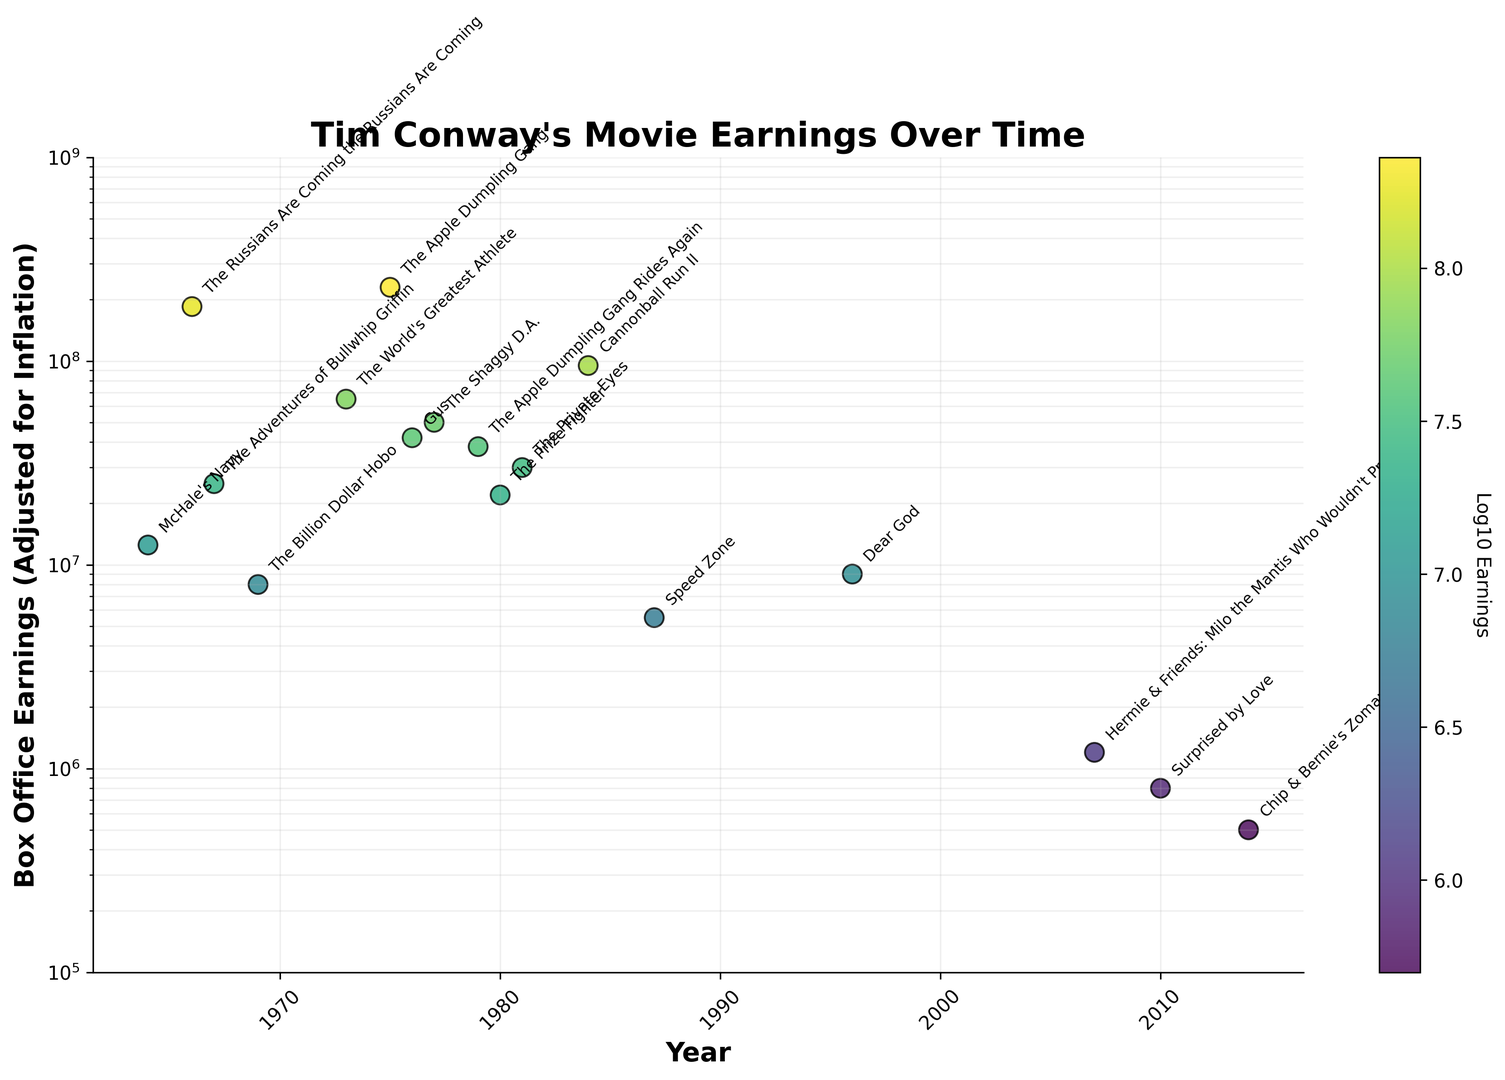Which Tim Conway movie has the highest box office earnings adjusted for inflation? Locate the highest point on the y-axis, which represents the highest earnings. The corresponding movie label is "The Apple Dumpling Gang".
Answer: The Apple Dumpling Gang Are there any movies released after the year 2000? If so, name one. Check the x-axis for years beyond 2000 and identify any points that fall in this range. "Hermie & Friends: Milo the Mantis Who Wouldn't Pray" released in 2007, "Surprised by Love" in 2010, and "Chip & Bernie's Zomance" in 2014 are applicable.
Answer: Hermie & Friends: Milo the Mantis Who Wouldn't Pray Which movie had a lower adjusted box office earning: "The Billion Dollar Hobo" or "Dear God"? Locate both movies on the plot and compare their positions on the y-axis. "The Billion Dollar Hobo" appears at approximately 8,000,000 while "Dear God" appears at roughly 9,000,000.
Answer: The Billion Dollar Hobo How many Tim Conway movies released in the 1980s are shown? Identify data points on the x-axis within the years 1980-1989 and count them. There are "The Prize Fighter" (1980), "The Private Eyes" (1981), and "Cannonball Run II" (1984).
Answer: 3 What is the average box office earnings (adjusted for inflation) for movies released in the 1970s? Identify the earnings for movies in the 1970s: "The World's Greatest Athlete" ($65,000,000), "The Apple Dumpling Gang" ($230,000,000), "Gus" ($42,000,000), "The Shaggy D.A." ($50,000,000), "The Billion Dollar Hobo" ($8,000,000), "The Apple Dumpling Gang Rides Again" ($38,000,000). Sum them up and divide by the number of movies. (65 + 230 + 42 + 50 + 8 + 38) / 6 = 433 / 6 = roughly $72,166,666.67
Answer: $72,166,666.67 Which movie in the 1960s had the highest earnings, and how much was it? Identify points in the 1960s and locate the highest one based on y-axis value. "The Russians Are Coming the Russians Are Coming" is the highest, with earnings of $185,000,000.
Answer: The Russians Are Coming the Russians Are Coming, $185,000,000 Which movie has the smallest marker size and what does the marker size represent in this plot? The smallest marker size corresponds to the smallest earnings. "Chip & Bernie's Zomance" has the smallest marker size. In this plot, the size represents the magnitude of the earnings in relation to other movies.
Answer: Chip & Bernie's Zomance, marker size represents earnings magnitude 